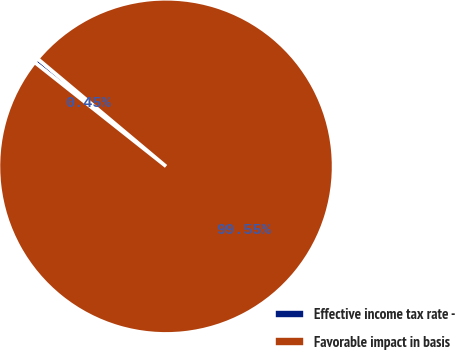Convert chart. <chart><loc_0><loc_0><loc_500><loc_500><pie_chart><fcel>Effective income tax rate -<fcel>Favorable impact in basis<nl><fcel>0.45%<fcel>99.55%<nl></chart> 